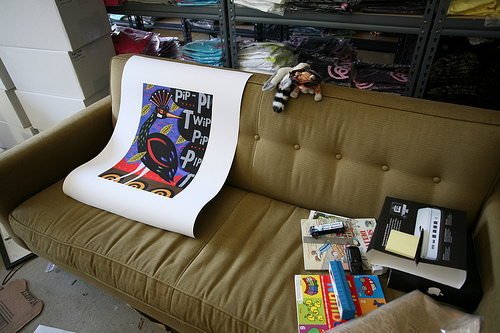<image>
Is the toy on the sofa? Yes. Looking at the image, I can see the toy is positioned on top of the sofa, with the sofa providing support. Where is the poster in relation to the couch? Is it on the couch? Yes. Looking at the image, I can see the poster is positioned on top of the couch, with the couch providing support. Where is the book in relation to the sofa? Is it under the sofa? No. The book is not positioned under the sofa. The vertical relationship between these objects is different. 